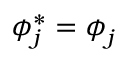<formula> <loc_0><loc_0><loc_500><loc_500>\phi _ { j } ^ { \ast } = \phi _ { j }</formula> 